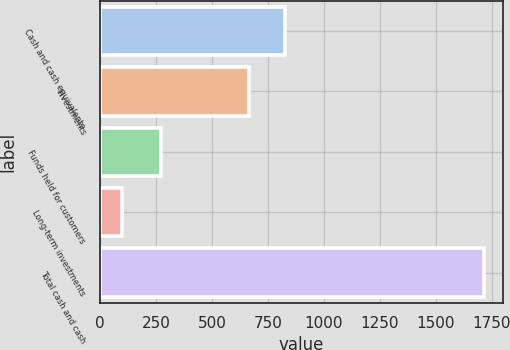<chart> <loc_0><loc_0><loc_500><loc_500><bar_chart><fcel>Cash and cash equivalents<fcel>Investments<fcel>Funds held for customers<fcel>Long-term investments<fcel>Total cash and cash<nl><fcel>827.7<fcel>666<fcel>272<fcel>97<fcel>1714<nl></chart> 